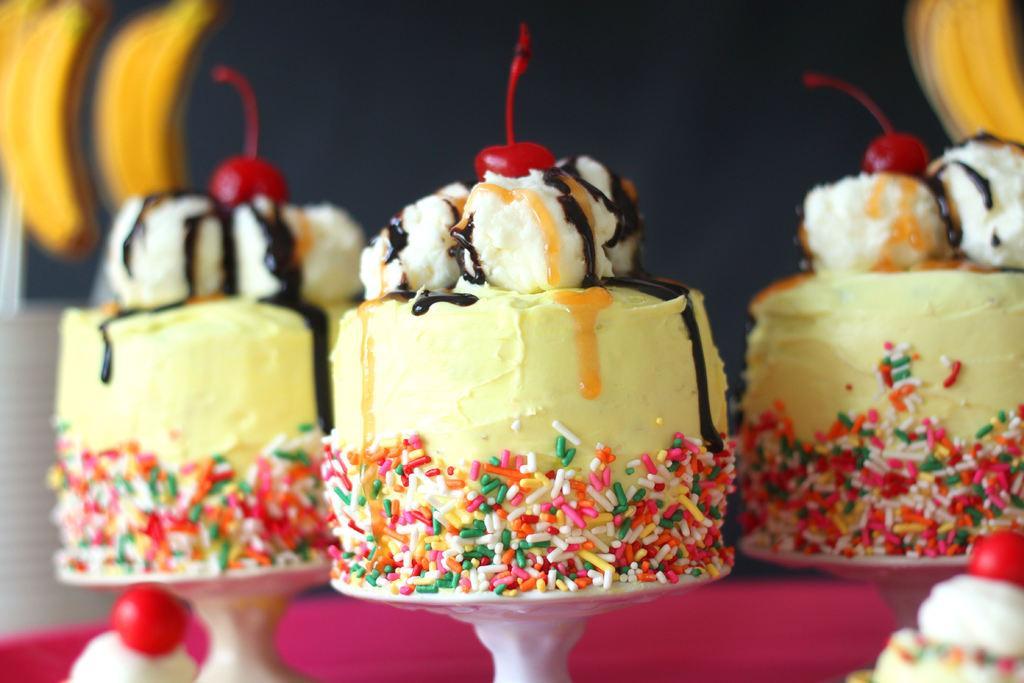Can you describe this image briefly? In this image we can see some cakes, cherries, bananas, and the background is blurred. 